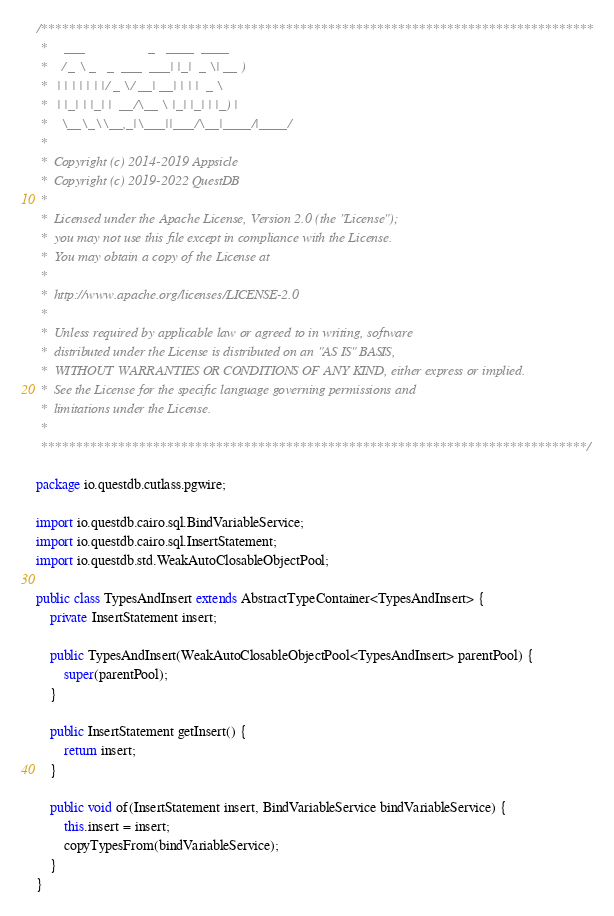Convert code to text. <code><loc_0><loc_0><loc_500><loc_500><_Java_>/*******************************************************************************
 *     ___                  _   ____  ____
 *    / _ \ _   _  ___  ___| |_|  _ \| __ )
 *   | | | | | | |/ _ \/ __| __| | | |  _ \
 *   | |_| | |_| |  __/\__ \ |_| |_| | |_) |
 *    \__\_\\__,_|\___||___/\__|____/|____/
 *
 *  Copyright (c) 2014-2019 Appsicle
 *  Copyright (c) 2019-2022 QuestDB
 *
 *  Licensed under the Apache License, Version 2.0 (the "License");
 *  you may not use this file except in compliance with the License.
 *  You may obtain a copy of the License at
 *
 *  http://www.apache.org/licenses/LICENSE-2.0
 *
 *  Unless required by applicable law or agreed to in writing, software
 *  distributed under the License is distributed on an "AS IS" BASIS,
 *  WITHOUT WARRANTIES OR CONDITIONS OF ANY KIND, either express or implied.
 *  See the License for the specific language governing permissions and
 *  limitations under the License.
 *
 ******************************************************************************/

package io.questdb.cutlass.pgwire;

import io.questdb.cairo.sql.BindVariableService;
import io.questdb.cairo.sql.InsertStatement;
import io.questdb.std.WeakAutoClosableObjectPool;

public class TypesAndInsert extends AbstractTypeContainer<TypesAndInsert> {
    private InsertStatement insert;

    public TypesAndInsert(WeakAutoClosableObjectPool<TypesAndInsert> parentPool) {
        super(parentPool);
    }

    public InsertStatement getInsert() {
        return insert;
    }

    public void of(InsertStatement insert, BindVariableService bindVariableService) {
        this.insert = insert;
        copyTypesFrom(bindVariableService);
    }
}
</code> 